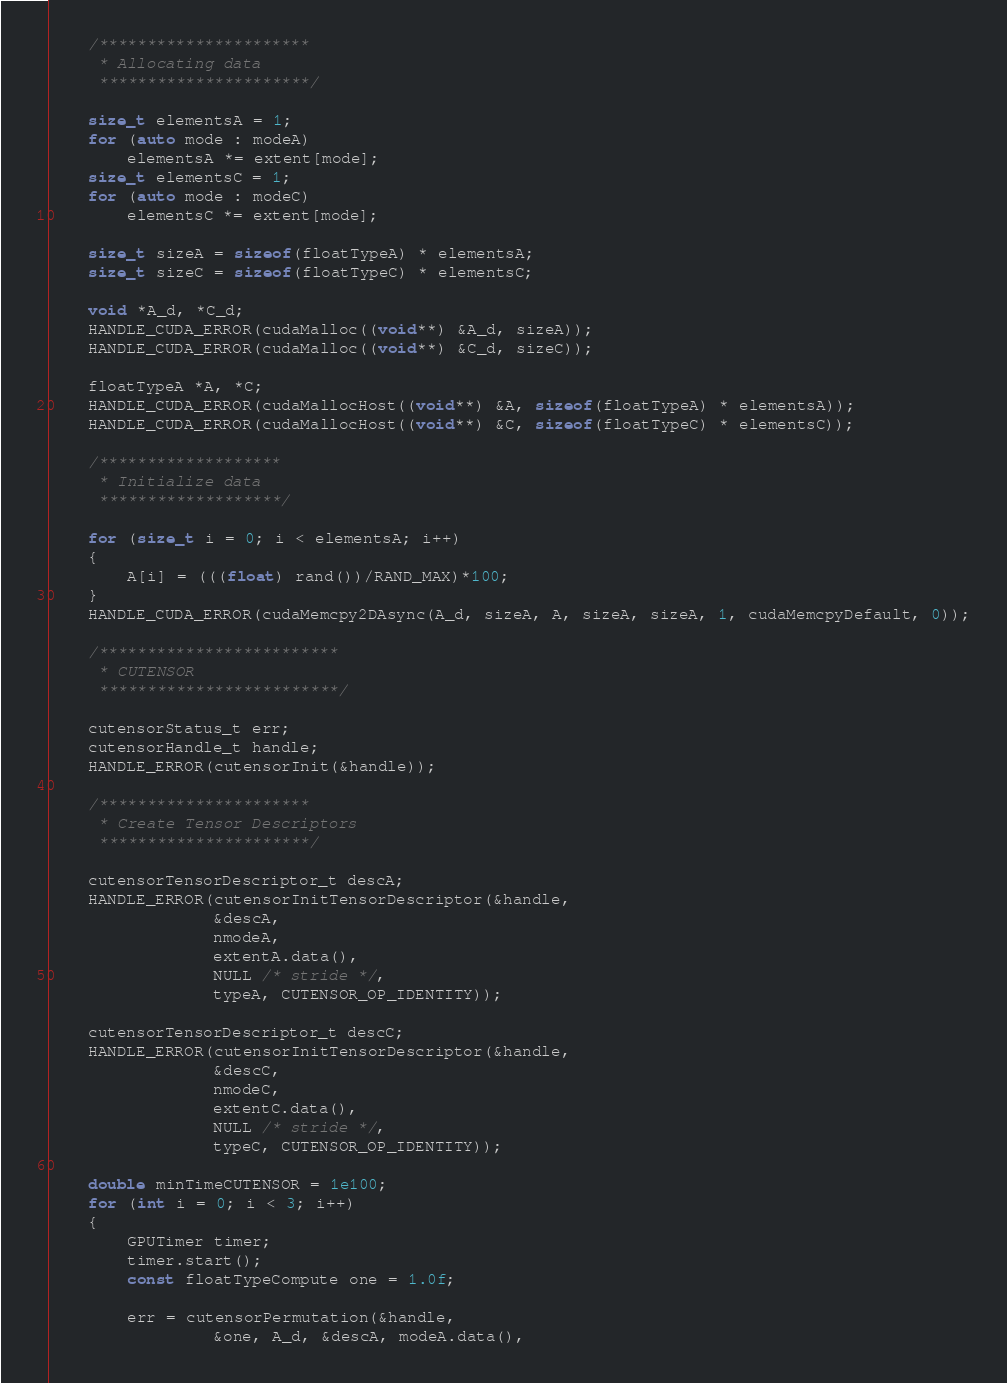Convert code to text. <code><loc_0><loc_0><loc_500><loc_500><_Cuda_>
    /**********************
     * Allocating data
     **********************/

    size_t elementsA = 1;
    for (auto mode : modeA)
        elementsA *= extent[mode];
    size_t elementsC = 1;
    for (auto mode : modeC)
        elementsC *= extent[mode];

    size_t sizeA = sizeof(floatTypeA) * elementsA;
    size_t sizeC = sizeof(floatTypeC) * elementsC;

    void *A_d, *C_d;
    HANDLE_CUDA_ERROR(cudaMalloc((void**) &A_d, sizeA));
    HANDLE_CUDA_ERROR(cudaMalloc((void**) &C_d, sizeC));

    floatTypeA *A, *C;
    HANDLE_CUDA_ERROR(cudaMallocHost((void**) &A, sizeof(floatTypeA) * elementsA));
    HANDLE_CUDA_ERROR(cudaMallocHost((void**) &C, sizeof(floatTypeC) * elementsC));

    /*******************
     * Initialize data
     *******************/

    for (size_t i = 0; i < elementsA; i++)
    {
        A[i] = (((float) rand())/RAND_MAX)*100;
    }
    HANDLE_CUDA_ERROR(cudaMemcpy2DAsync(A_d, sizeA, A, sizeA, sizeA, 1, cudaMemcpyDefault, 0));

    /*************************
     * CUTENSOR
     *************************/

    cutensorStatus_t err;
    cutensorHandle_t handle;
    HANDLE_ERROR(cutensorInit(&handle));

    /**********************
     * Create Tensor Descriptors
     **********************/

    cutensorTensorDescriptor_t descA;
    HANDLE_ERROR(cutensorInitTensorDescriptor(&handle,
                 &descA,
                 nmodeA,
                 extentA.data(),
                 NULL /* stride */,
                 typeA, CUTENSOR_OP_IDENTITY));

    cutensorTensorDescriptor_t descC;
    HANDLE_ERROR(cutensorInitTensorDescriptor(&handle,
                 &descC,
                 nmodeC,
                 extentC.data(),
                 NULL /* stride */,
                 typeC, CUTENSOR_OP_IDENTITY));

    double minTimeCUTENSOR = 1e100;
    for (int i = 0; i < 3; i++)
    {
        GPUTimer timer;
        timer.start();
        const floatTypeCompute one = 1.0f;

        err = cutensorPermutation(&handle,
                 &one, A_d, &descA, modeA.data(),</code> 